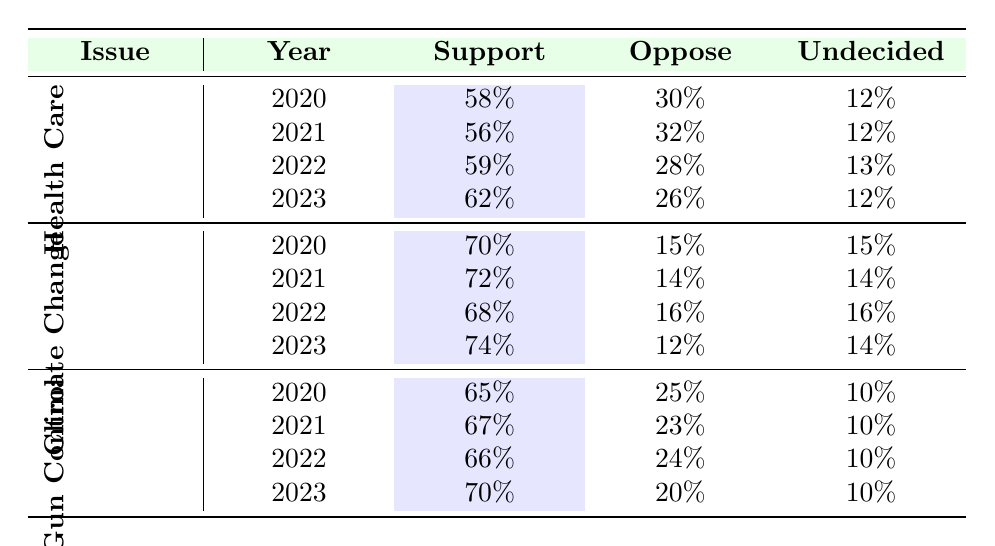What was the support percentage for single-payer health care in Vermont in 2022? The table shows that the support for single-payer health care in 2022 was 59%.
Answer: 59% What is the highest support percentage for aggressive action on climate change recorded in the table? By reviewing the climate change issue data across all years, 74% in 2023 is the highest recorded support.
Answer: 74% In which year did support for stricter gun control laws show the biggest increase? The changes in support for stricter gun laws are: 2020 to 2021 (2%), 2021 to 2022 (1%), and 2022 to 2023 (4%). The biggest increase was from 2022 to 2023.
Answer: 4% Is the percentage of undecided voters regarding health care the same in 2020 and 2023? In 2020, the percentage of undecided voters was 12%, and in 2023 it remains the same at 12%, so they are equal.
Answer: Yes What was the average support for climate change action across the years represented in the table? The support percentages are 70% (2020), 72% (2021), 68% (2022), and 74% (2023). Summing them gives 284%, and dividing by 4 gives an average of 71%.
Answer: 71% 